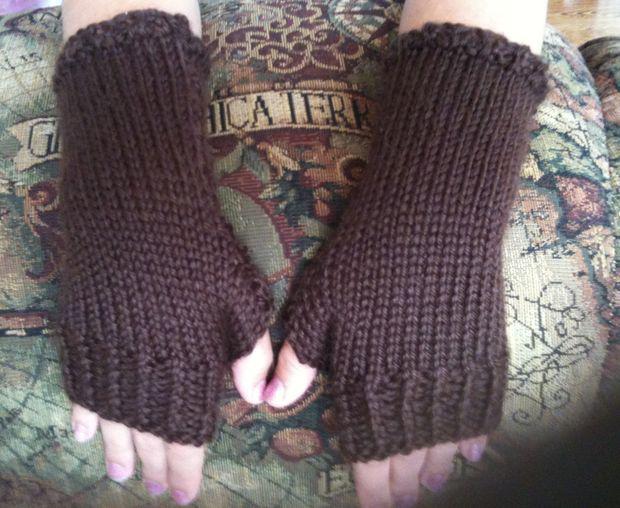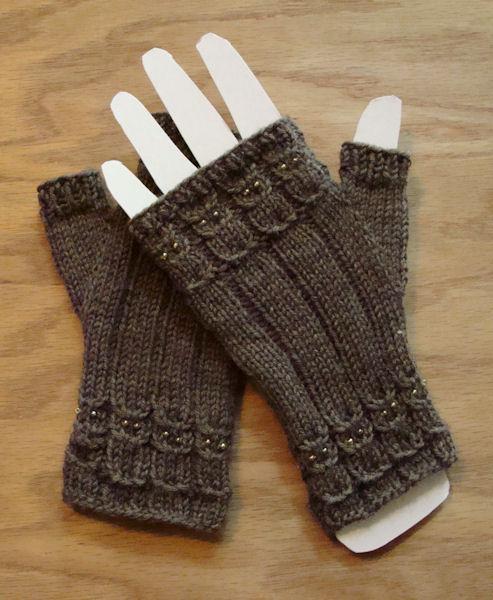The first image is the image on the left, the second image is the image on the right. Given the left and right images, does the statement "There is at least one human hand in the image on the right." hold true? Answer yes or no. No. 